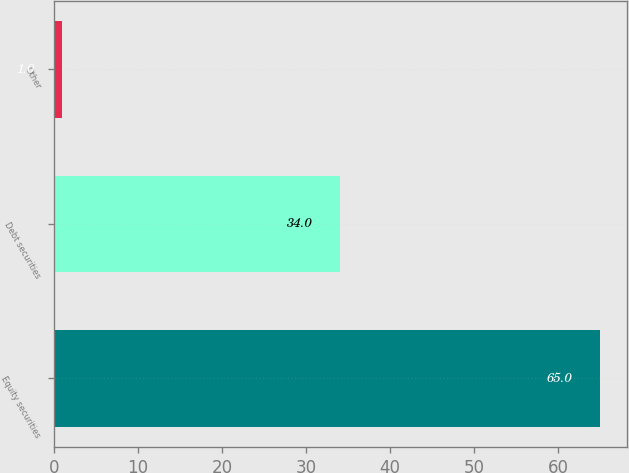<chart> <loc_0><loc_0><loc_500><loc_500><bar_chart><fcel>Equity securities<fcel>Debt securities<fcel>Other<nl><fcel>65<fcel>34<fcel>1<nl></chart> 